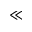<formula> <loc_0><loc_0><loc_500><loc_500>\ll</formula> 